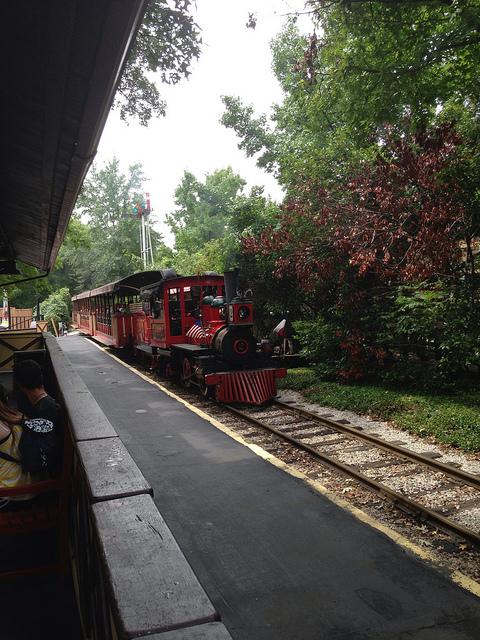Is this a tourist train?
Short answer required. Yes. Is this a subway train?
Keep it brief. No. Could the train be coal powered?
Quick response, please. Yes. 